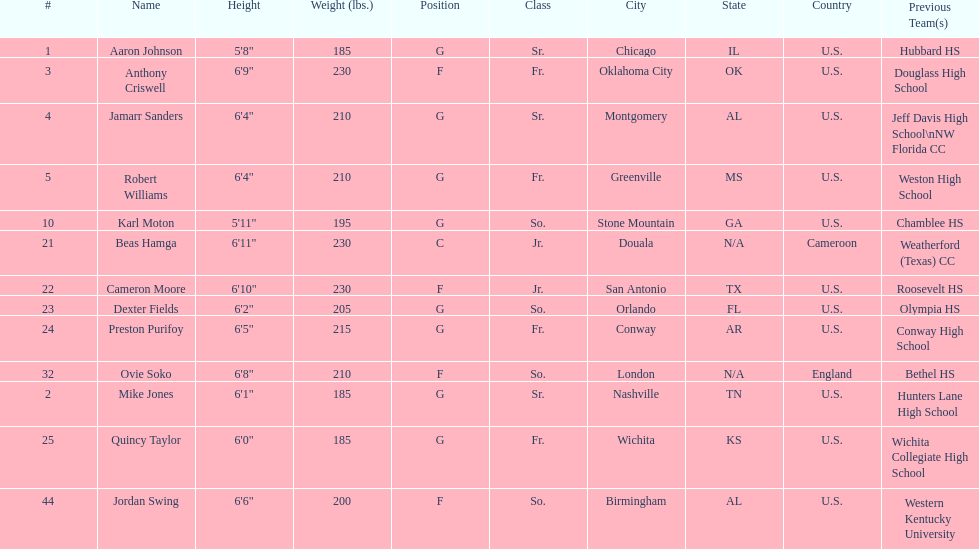Other than soko, who are the players? Aaron Johnson, Anthony Criswell, Jamarr Sanders, Robert Williams, Karl Moton, Beas Hamga, Cameron Moore, Dexter Fields, Preston Purifoy, Mike Jones, Quincy Taylor, Jordan Swing. Of those players, who is a player that is not from the us? Beas Hamga. 